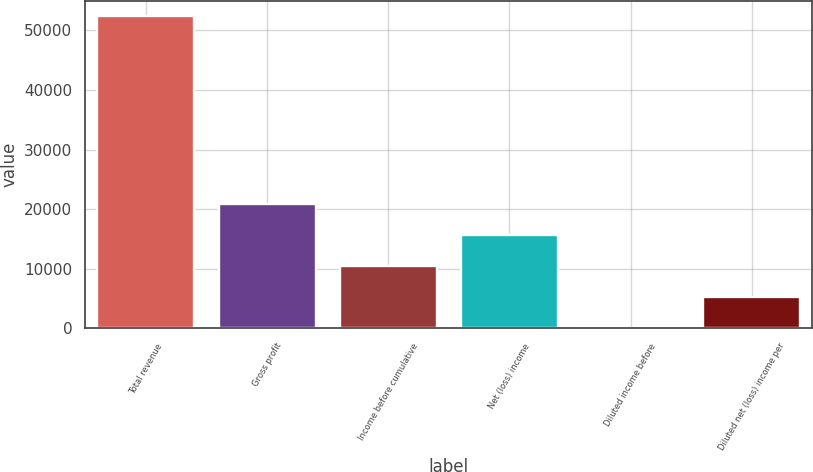<chart> <loc_0><loc_0><loc_500><loc_500><bar_chart><fcel>Total revenue<fcel>Gross profit<fcel>Income before cumulative<fcel>Net (loss) income<fcel>Diluted income before<fcel>Diluted net (loss) income per<nl><fcel>52404<fcel>20961.7<fcel>10480.9<fcel>15721.3<fcel>0.13<fcel>5240.52<nl></chart> 